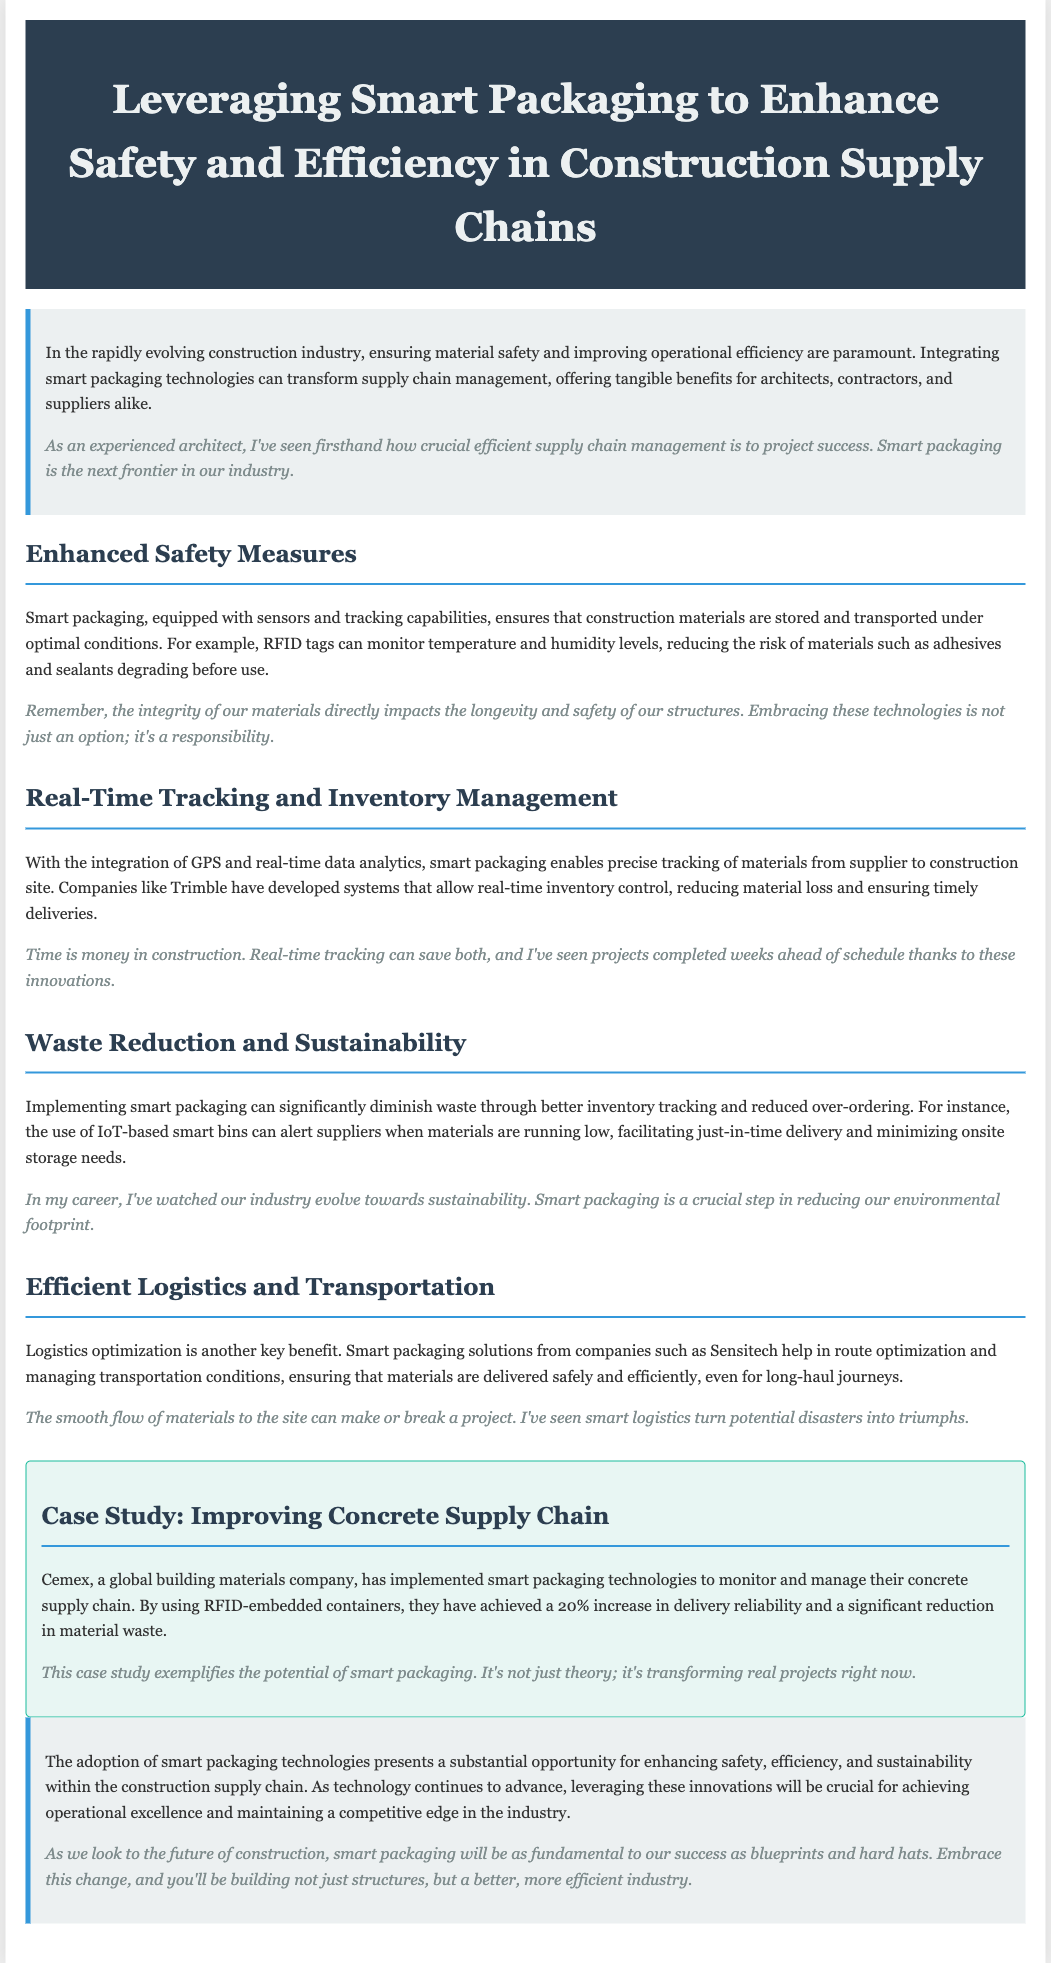What is the title of the document? The title is provided in the header section of the document.
Answer: Leveraging Smart Packaging to Enhance Safety and Efficiency in Construction Supply Chains What technology is used to monitor temperature and humidity levels? The document discusses the use of RFID technology for monitoring conditions of materials.
Answer: RFID tags What percentage increase in delivery reliability did Cemex achieve? The case study section notes the impact of smart packaging on Cemex's delivery reliability.
Answer: 20% What company developed systems for real-time inventory control? The document mentions a specific company related to inventory tracking solutions.
Answer: Trimble What is one example of a smart packaging technology mentioned? The document provides examples of technologies integrated in smart packaging.
Answer: IoT-based smart bins Why is embracing smart packaging considered a responsibility? This is elaborated in the Enhanced Safety Measures section, highlighting the impact on structures' safety.
Answer: The integrity of materials What kind of tracking does smart packaging provide? The document indicates the capabilities associated with smart packaging in the context of supply chains.
Answer: Real-time tracking What is one benefit of logistics optimization mentioned? The document states a specific benefit associated with smart packaging in logistics.
Answer: Ensuring safe delivery 